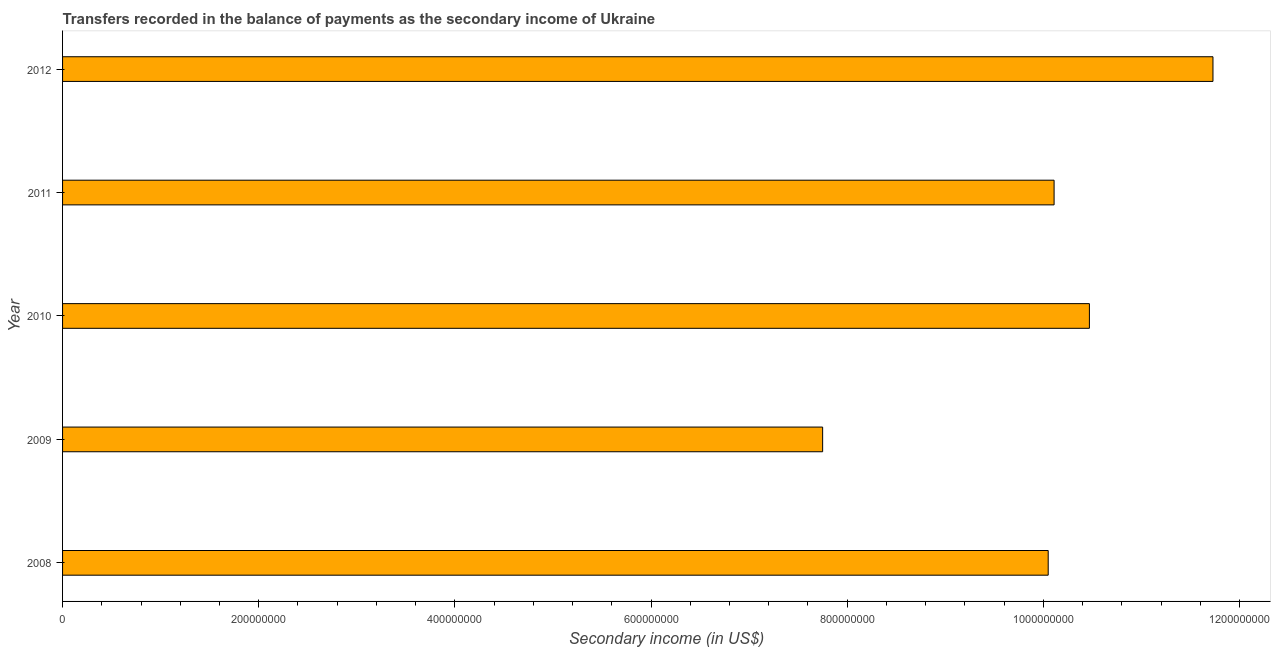What is the title of the graph?
Provide a short and direct response. Transfers recorded in the balance of payments as the secondary income of Ukraine. What is the label or title of the X-axis?
Give a very brief answer. Secondary income (in US$). What is the label or title of the Y-axis?
Provide a short and direct response. Year. What is the amount of secondary income in 2011?
Offer a very short reply. 1.01e+09. Across all years, what is the maximum amount of secondary income?
Give a very brief answer. 1.17e+09. Across all years, what is the minimum amount of secondary income?
Offer a very short reply. 7.75e+08. What is the sum of the amount of secondary income?
Keep it short and to the point. 5.01e+09. What is the difference between the amount of secondary income in 2011 and 2012?
Keep it short and to the point. -1.62e+08. What is the average amount of secondary income per year?
Offer a very short reply. 1.00e+09. What is the median amount of secondary income?
Provide a short and direct response. 1.01e+09. In how many years, is the amount of secondary income greater than 280000000 US$?
Make the answer very short. 5. What is the ratio of the amount of secondary income in 2011 to that in 2012?
Provide a succinct answer. 0.86. What is the difference between the highest and the second highest amount of secondary income?
Your answer should be very brief. 1.26e+08. What is the difference between the highest and the lowest amount of secondary income?
Offer a very short reply. 3.98e+08. In how many years, is the amount of secondary income greater than the average amount of secondary income taken over all years?
Offer a terse response. 4. How many bars are there?
Make the answer very short. 5. What is the Secondary income (in US$) in 2008?
Offer a terse response. 1.00e+09. What is the Secondary income (in US$) in 2009?
Offer a very short reply. 7.75e+08. What is the Secondary income (in US$) of 2010?
Keep it short and to the point. 1.05e+09. What is the Secondary income (in US$) of 2011?
Ensure brevity in your answer.  1.01e+09. What is the Secondary income (in US$) of 2012?
Keep it short and to the point. 1.17e+09. What is the difference between the Secondary income (in US$) in 2008 and 2009?
Keep it short and to the point. 2.30e+08. What is the difference between the Secondary income (in US$) in 2008 and 2010?
Ensure brevity in your answer.  -4.20e+07. What is the difference between the Secondary income (in US$) in 2008 and 2011?
Your answer should be compact. -6.00e+06. What is the difference between the Secondary income (in US$) in 2008 and 2012?
Offer a very short reply. -1.68e+08. What is the difference between the Secondary income (in US$) in 2009 and 2010?
Offer a terse response. -2.72e+08. What is the difference between the Secondary income (in US$) in 2009 and 2011?
Ensure brevity in your answer.  -2.36e+08. What is the difference between the Secondary income (in US$) in 2009 and 2012?
Your answer should be compact. -3.98e+08. What is the difference between the Secondary income (in US$) in 2010 and 2011?
Provide a short and direct response. 3.60e+07. What is the difference between the Secondary income (in US$) in 2010 and 2012?
Ensure brevity in your answer.  -1.26e+08. What is the difference between the Secondary income (in US$) in 2011 and 2012?
Your answer should be very brief. -1.62e+08. What is the ratio of the Secondary income (in US$) in 2008 to that in 2009?
Keep it short and to the point. 1.3. What is the ratio of the Secondary income (in US$) in 2008 to that in 2012?
Provide a short and direct response. 0.86. What is the ratio of the Secondary income (in US$) in 2009 to that in 2010?
Give a very brief answer. 0.74. What is the ratio of the Secondary income (in US$) in 2009 to that in 2011?
Give a very brief answer. 0.77. What is the ratio of the Secondary income (in US$) in 2009 to that in 2012?
Your answer should be compact. 0.66. What is the ratio of the Secondary income (in US$) in 2010 to that in 2011?
Give a very brief answer. 1.04. What is the ratio of the Secondary income (in US$) in 2010 to that in 2012?
Keep it short and to the point. 0.89. What is the ratio of the Secondary income (in US$) in 2011 to that in 2012?
Your response must be concise. 0.86. 